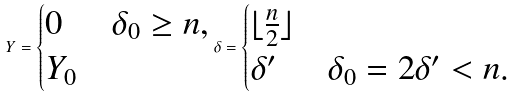Convert formula to latex. <formula><loc_0><loc_0><loc_500><loc_500>Y = \begin{cases} 0 & \delta _ { 0 } \geq n , \\ Y _ { 0 } & \end{cases} \delta = \begin{cases} \lfloor \frac { n } { 2 } \rfloor & \\ \delta ^ { \prime } & \delta _ { 0 } = 2 \delta ^ { \prime } < n . \end{cases}</formula> 